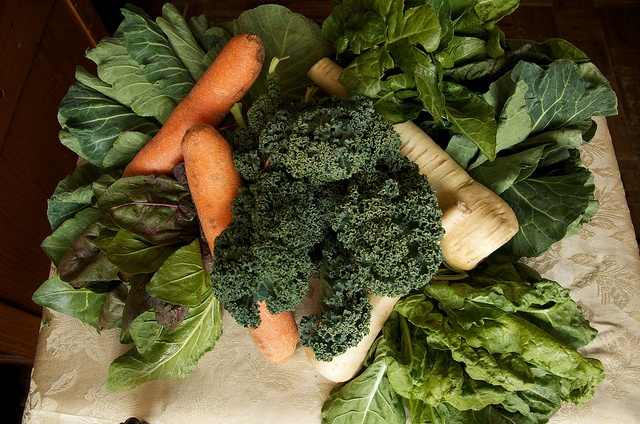Describe the objects in this image and their specific colors. I can see broccoli in black and darkgreen tones, carrot in black, orange, red, brown, and tan tones, and carrot in black, red, brown, orange, and maroon tones in this image. 